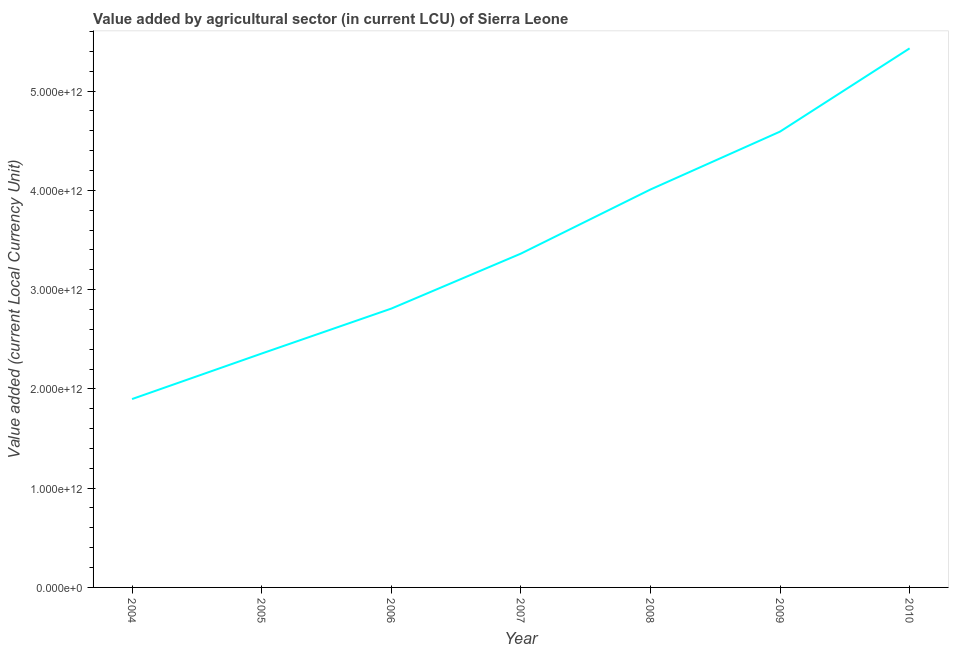What is the value added by agriculture sector in 2006?
Ensure brevity in your answer.  2.81e+12. Across all years, what is the maximum value added by agriculture sector?
Keep it short and to the point. 5.43e+12. Across all years, what is the minimum value added by agriculture sector?
Ensure brevity in your answer.  1.90e+12. In which year was the value added by agriculture sector maximum?
Your response must be concise. 2010. In which year was the value added by agriculture sector minimum?
Keep it short and to the point. 2004. What is the sum of the value added by agriculture sector?
Your answer should be very brief. 2.45e+13. What is the difference between the value added by agriculture sector in 2005 and 2009?
Your answer should be compact. -2.24e+12. What is the average value added by agriculture sector per year?
Provide a short and direct response. 3.49e+12. What is the median value added by agriculture sector?
Your answer should be very brief. 3.36e+12. What is the ratio of the value added by agriculture sector in 2008 to that in 2010?
Provide a succinct answer. 0.74. What is the difference between the highest and the second highest value added by agriculture sector?
Keep it short and to the point. 8.38e+11. What is the difference between the highest and the lowest value added by agriculture sector?
Offer a terse response. 3.53e+12. What is the difference between two consecutive major ticks on the Y-axis?
Keep it short and to the point. 1.00e+12. Does the graph contain any zero values?
Your answer should be compact. No. Does the graph contain grids?
Your answer should be very brief. No. What is the title of the graph?
Provide a succinct answer. Value added by agricultural sector (in current LCU) of Sierra Leone. What is the label or title of the X-axis?
Offer a very short reply. Year. What is the label or title of the Y-axis?
Your response must be concise. Value added (current Local Currency Unit). What is the Value added (current Local Currency Unit) of 2004?
Keep it short and to the point. 1.90e+12. What is the Value added (current Local Currency Unit) in 2005?
Offer a very short reply. 2.36e+12. What is the Value added (current Local Currency Unit) of 2006?
Make the answer very short. 2.81e+12. What is the Value added (current Local Currency Unit) of 2007?
Provide a succinct answer. 3.36e+12. What is the Value added (current Local Currency Unit) in 2008?
Keep it short and to the point. 4.01e+12. What is the Value added (current Local Currency Unit) of 2009?
Provide a succinct answer. 4.59e+12. What is the Value added (current Local Currency Unit) of 2010?
Make the answer very short. 5.43e+12. What is the difference between the Value added (current Local Currency Unit) in 2004 and 2005?
Ensure brevity in your answer.  -4.58e+11. What is the difference between the Value added (current Local Currency Unit) in 2004 and 2006?
Offer a terse response. -9.11e+11. What is the difference between the Value added (current Local Currency Unit) in 2004 and 2007?
Provide a succinct answer. -1.46e+12. What is the difference between the Value added (current Local Currency Unit) in 2004 and 2008?
Offer a terse response. -2.11e+12. What is the difference between the Value added (current Local Currency Unit) in 2004 and 2009?
Offer a very short reply. -2.69e+12. What is the difference between the Value added (current Local Currency Unit) in 2004 and 2010?
Offer a very short reply. -3.53e+12. What is the difference between the Value added (current Local Currency Unit) in 2005 and 2006?
Provide a succinct answer. -4.53e+11. What is the difference between the Value added (current Local Currency Unit) in 2005 and 2007?
Offer a terse response. -1.01e+12. What is the difference between the Value added (current Local Currency Unit) in 2005 and 2008?
Provide a succinct answer. -1.65e+12. What is the difference between the Value added (current Local Currency Unit) in 2005 and 2009?
Provide a succinct answer. -2.24e+12. What is the difference between the Value added (current Local Currency Unit) in 2005 and 2010?
Your response must be concise. -3.07e+12. What is the difference between the Value added (current Local Currency Unit) in 2006 and 2007?
Provide a succinct answer. -5.54e+11. What is the difference between the Value added (current Local Currency Unit) in 2006 and 2008?
Your response must be concise. -1.20e+12. What is the difference between the Value added (current Local Currency Unit) in 2006 and 2009?
Give a very brief answer. -1.78e+12. What is the difference between the Value added (current Local Currency Unit) in 2006 and 2010?
Ensure brevity in your answer.  -2.62e+12. What is the difference between the Value added (current Local Currency Unit) in 2007 and 2008?
Offer a terse response. -6.46e+11. What is the difference between the Value added (current Local Currency Unit) in 2007 and 2009?
Your answer should be compact. -1.23e+12. What is the difference between the Value added (current Local Currency Unit) in 2007 and 2010?
Your answer should be compact. -2.07e+12. What is the difference between the Value added (current Local Currency Unit) in 2008 and 2009?
Your answer should be very brief. -5.83e+11. What is the difference between the Value added (current Local Currency Unit) in 2008 and 2010?
Your answer should be very brief. -1.42e+12. What is the difference between the Value added (current Local Currency Unit) in 2009 and 2010?
Offer a terse response. -8.38e+11. What is the ratio of the Value added (current Local Currency Unit) in 2004 to that in 2005?
Make the answer very short. 0.81. What is the ratio of the Value added (current Local Currency Unit) in 2004 to that in 2006?
Make the answer very short. 0.68. What is the ratio of the Value added (current Local Currency Unit) in 2004 to that in 2007?
Ensure brevity in your answer.  0.56. What is the ratio of the Value added (current Local Currency Unit) in 2004 to that in 2008?
Ensure brevity in your answer.  0.47. What is the ratio of the Value added (current Local Currency Unit) in 2004 to that in 2009?
Offer a terse response. 0.41. What is the ratio of the Value added (current Local Currency Unit) in 2004 to that in 2010?
Provide a succinct answer. 0.35. What is the ratio of the Value added (current Local Currency Unit) in 2005 to that in 2006?
Offer a very short reply. 0.84. What is the ratio of the Value added (current Local Currency Unit) in 2005 to that in 2007?
Ensure brevity in your answer.  0.7. What is the ratio of the Value added (current Local Currency Unit) in 2005 to that in 2008?
Offer a terse response. 0.59. What is the ratio of the Value added (current Local Currency Unit) in 2005 to that in 2009?
Provide a short and direct response. 0.51. What is the ratio of the Value added (current Local Currency Unit) in 2005 to that in 2010?
Ensure brevity in your answer.  0.43. What is the ratio of the Value added (current Local Currency Unit) in 2006 to that in 2007?
Your answer should be compact. 0.83. What is the ratio of the Value added (current Local Currency Unit) in 2006 to that in 2008?
Your answer should be compact. 0.7. What is the ratio of the Value added (current Local Currency Unit) in 2006 to that in 2009?
Give a very brief answer. 0.61. What is the ratio of the Value added (current Local Currency Unit) in 2006 to that in 2010?
Provide a succinct answer. 0.52. What is the ratio of the Value added (current Local Currency Unit) in 2007 to that in 2008?
Give a very brief answer. 0.84. What is the ratio of the Value added (current Local Currency Unit) in 2007 to that in 2009?
Keep it short and to the point. 0.73. What is the ratio of the Value added (current Local Currency Unit) in 2007 to that in 2010?
Offer a terse response. 0.62. What is the ratio of the Value added (current Local Currency Unit) in 2008 to that in 2009?
Your answer should be very brief. 0.87. What is the ratio of the Value added (current Local Currency Unit) in 2008 to that in 2010?
Offer a very short reply. 0.74. What is the ratio of the Value added (current Local Currency Unit) in 2009 to that in 2010?
Your answer should be compact. 0.85. 